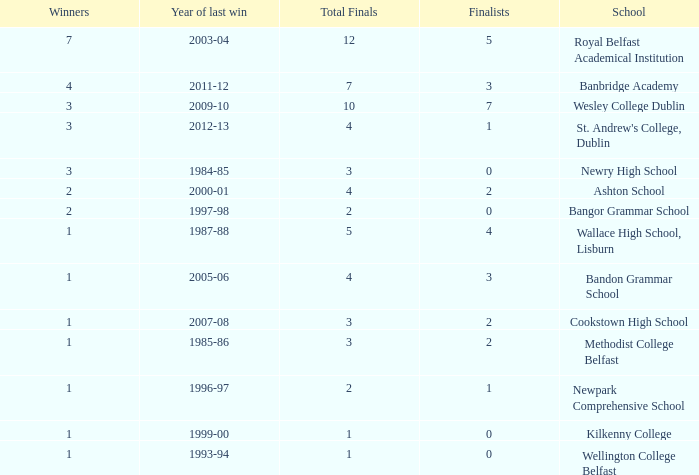What is the name of the school where the year of last win is 1985-86? Methodist College Belfast. 